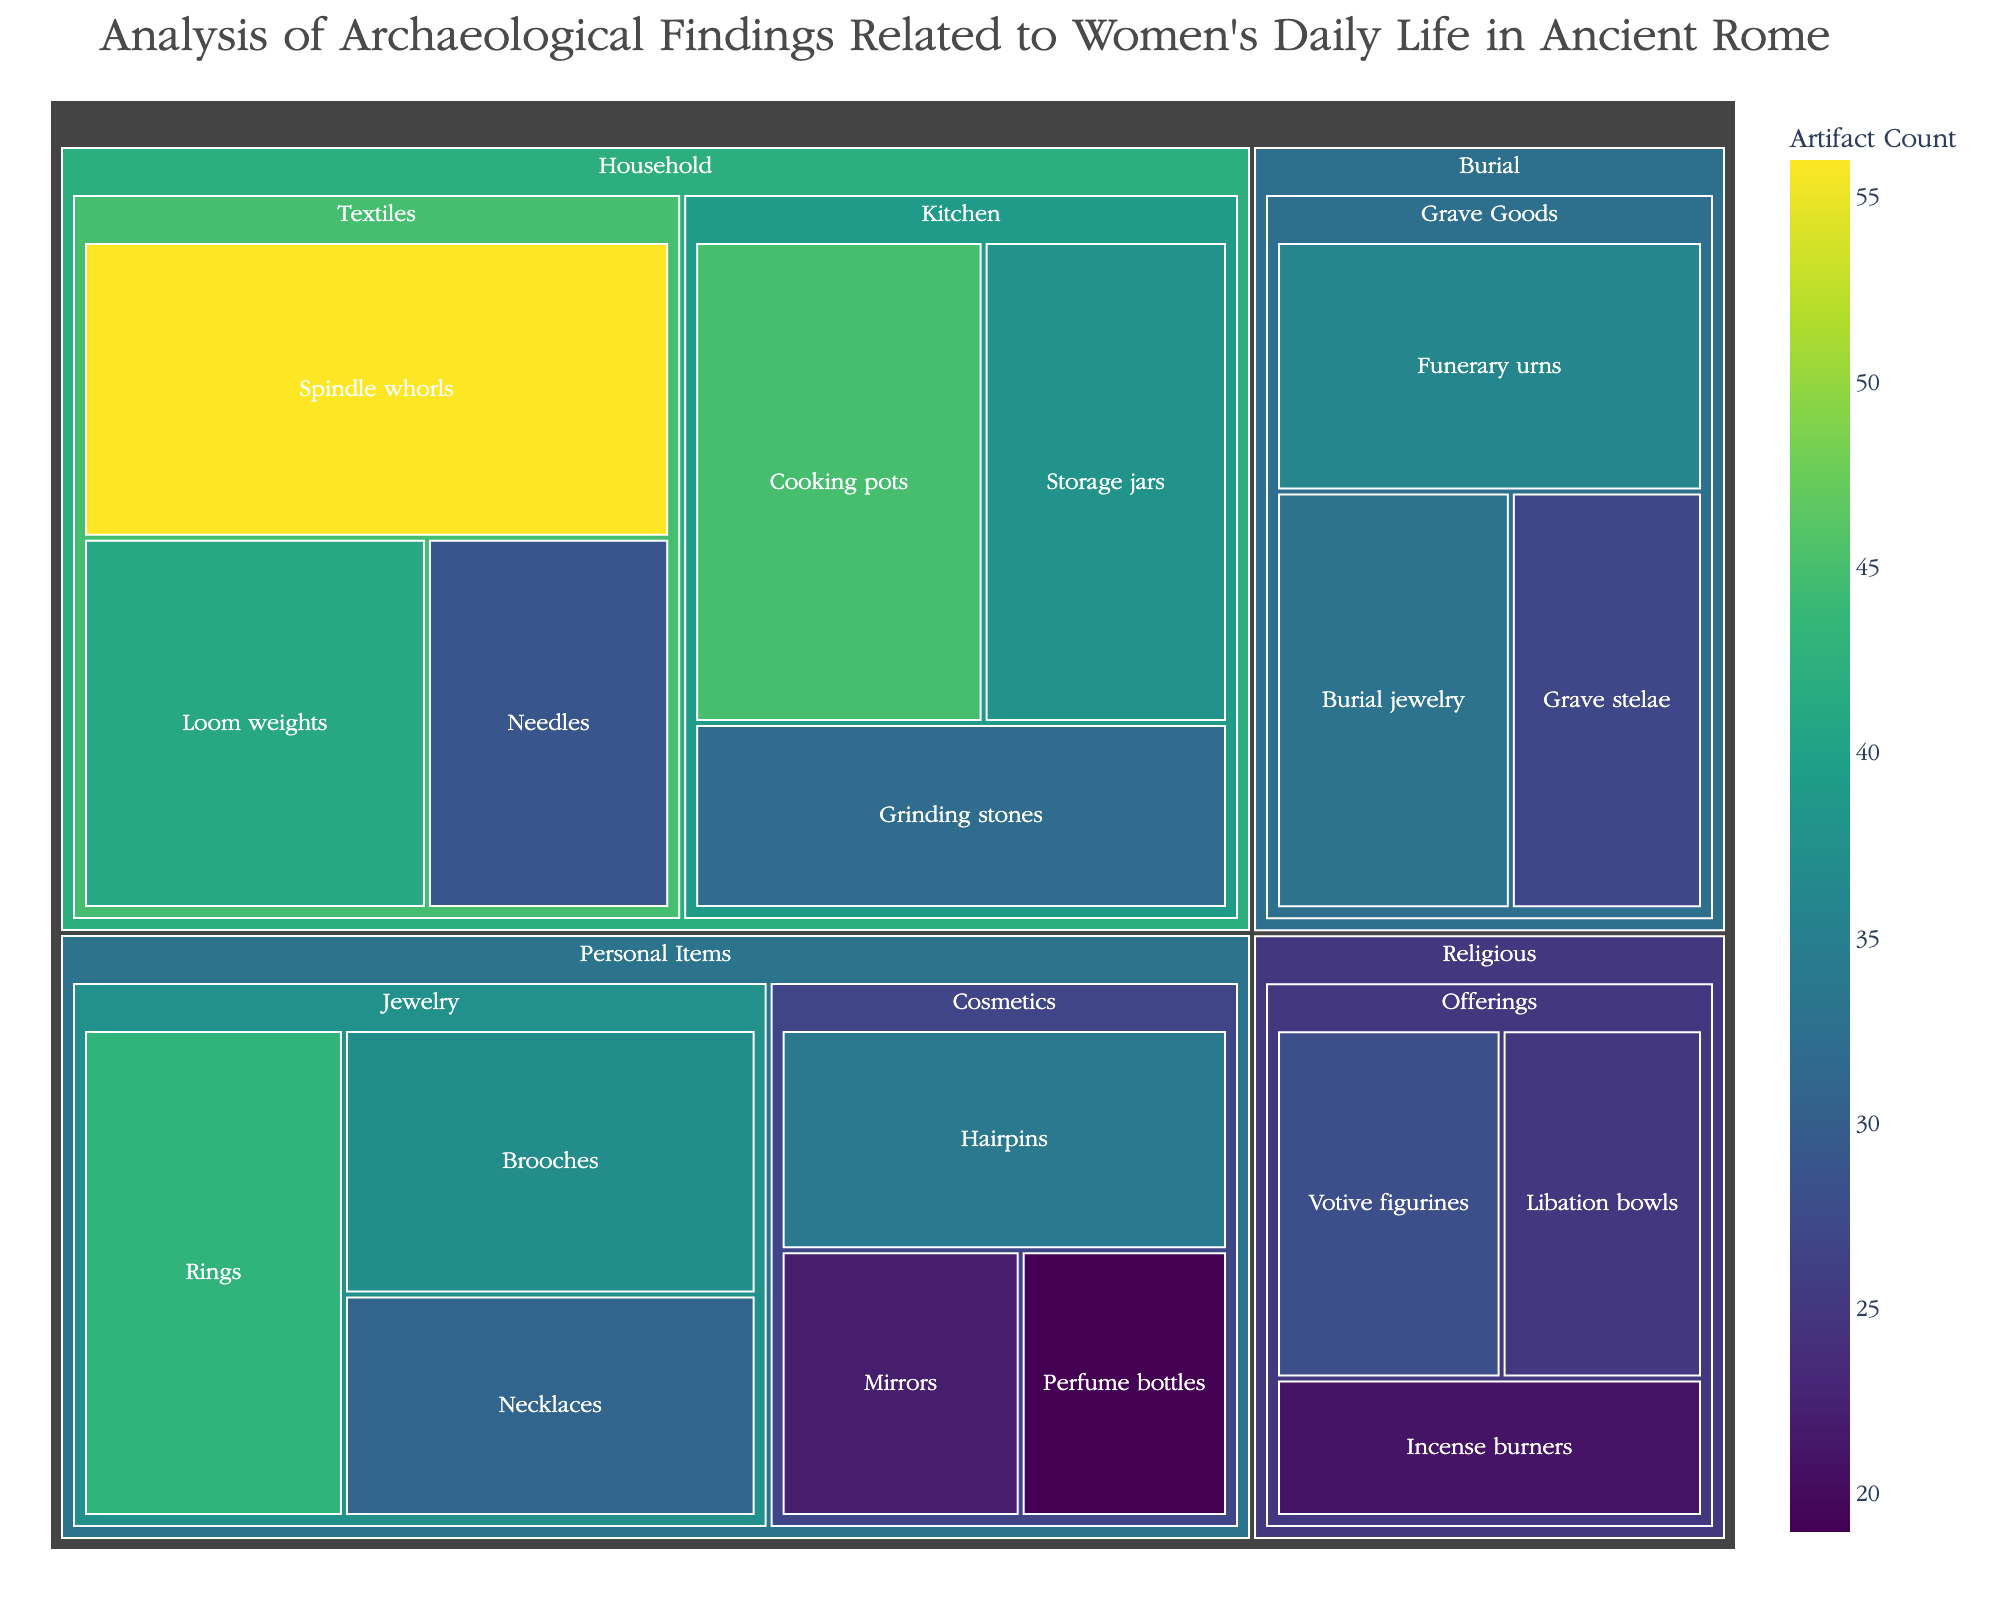What's the title of the Treemap? The title is always provided at the top of the Treemap plot, summarizing the main focus of the visualization.
Answer: Analysis of Archaeological Findings Related to Women's Daily Life in Ancient Rome Which category has the highest total value of artifacts? To find the category with the highest total value, sum the values of the subcategories within each category. The Household category has the highest total value when adding up its subcategories (45 + 32 + 38 + 56 + 41 + 29 = 241).
Answer: Household How many artifacts are in the Personal Items category? Sum the values of all items under the Personal Items category: Jewelry (37 + 43 + 31) and Cosmetics (22 + 19 + 34) = 37 + 43 + 31 + 22 + 19 + 34 = 186.
Answer: 186 Which artifact type has the lowest value in the Religious category? Compare the values of all items under the Religious category: Votive figurines (28), Libation bowls (25), and Incense burners (21). Incense burners have the lowest value.
Answer: Incense burners What is the difference in value between Cooking pots and Spindle whorls? Subtract the value of Cooking pots (45) from Spindle whorls (56) to find the difference: 56 - 45.
Answer: 11 Which subcategory within Household has the most artifacts? Compare the total values of Kitchen subcategory (45 + 32 + 38 = 115) and Textiles subcategory (56 + 41 + 29 = 126). Textiles have the most artifacts.
Answer: Textiles What is the average value of items in the Burial category? Sum the values of all items in the Burial category (36 + 27 + 33 = 96) and divide by the number of items (3): 96 / 3.
Answer: 32 Which artifact type has the highest value in the Kitchen subcategory? Compare the values of all items under the Kitchen subcategory: Cooking pots (45), Grinding stones (32), and Storage jars (38). Cooking pots have the highest value.
Answer: Cooking pots Are there more artifacts in the Textiles subcategory or the Jewelry subcategory? Compare the total values of the Textiles subcategory (56 + 41 + 29 = 126) and Jewelry subcategory (37 + 43 + 31 = 111). Textiles have more artifacts.
Answer: Textiles What's the total value of Mirror and Hairpins combined in the Cosmetics subcategory? Sum the values of Mirrors (22) and Hairpins (34): 22 + 34.
Answer: 56 